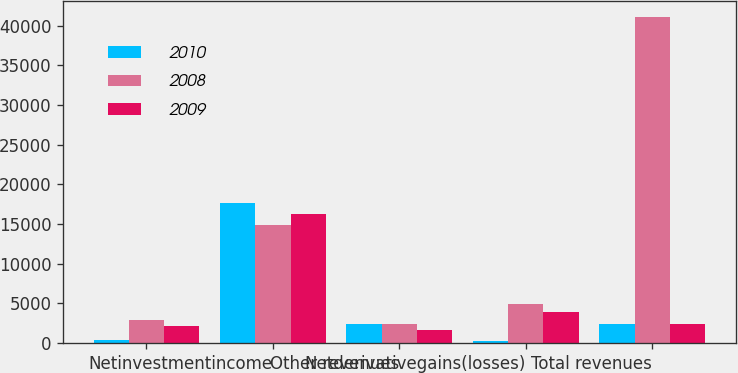<chart> <loc_0><loc_0><loc_500><loc_500><stacked_bar_chart><ecel><fcel>Unnamed: 1<fcel>Netinvestmentincome<fcel>Other revenues<fcel>Netderivativegains(losses)<fcel>Total revenues<nl><fcel>2010<fcel>392<fcel>17615<fcel>2328<fcel>265<fcel>2384<nl><fcel>2008<fcel>2906<fcel>14837<fcel>2329<fcel>4866<fcel>41057<nl><fcel>2009<fcel>2098<fcel>16289<fcel>1586<fcel>3910<fcel>2384<nl></chart> 